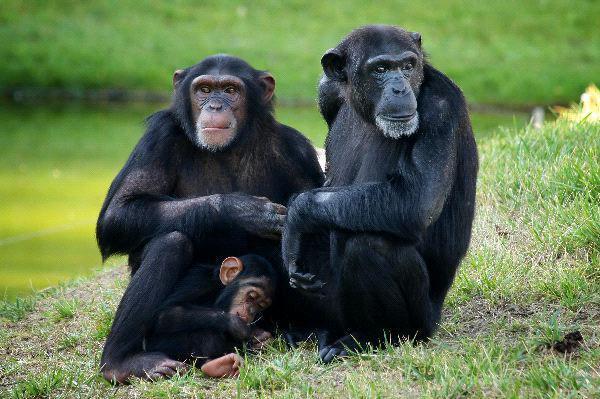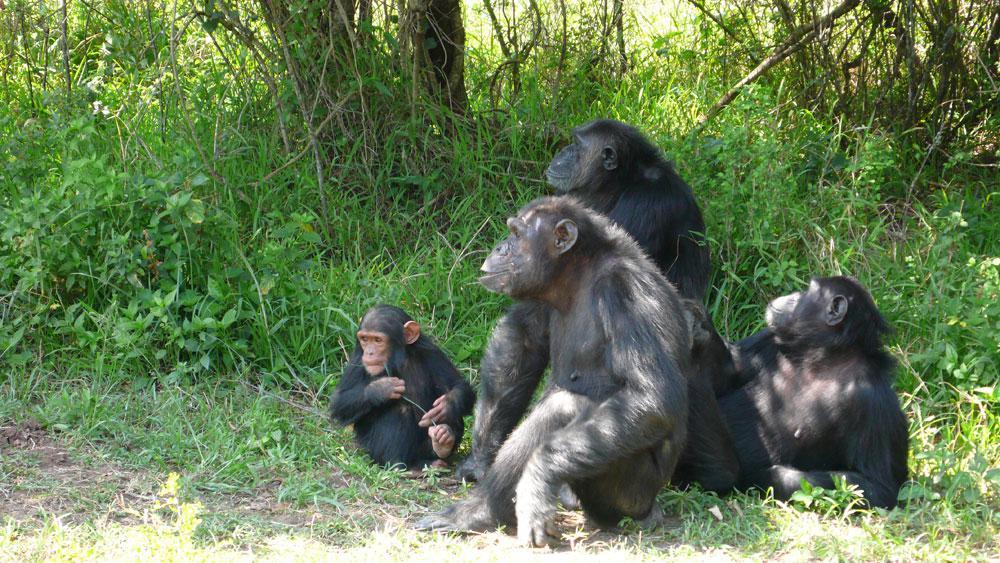The first image is the image on the left, the second image is the image on the right. For the images shown, is this caption "There is atleast one extremely small baby monkey sitting next to a bigger adult sized monkey." true? Answer yes or no. Yes. The first image is the image on the left, the second image is the image on the right. For the images displayed, is the sentence "None of the chimpanzees appear to be young babies or toddlers; all are fully grown." factually correct? Answer yes or no. No. 